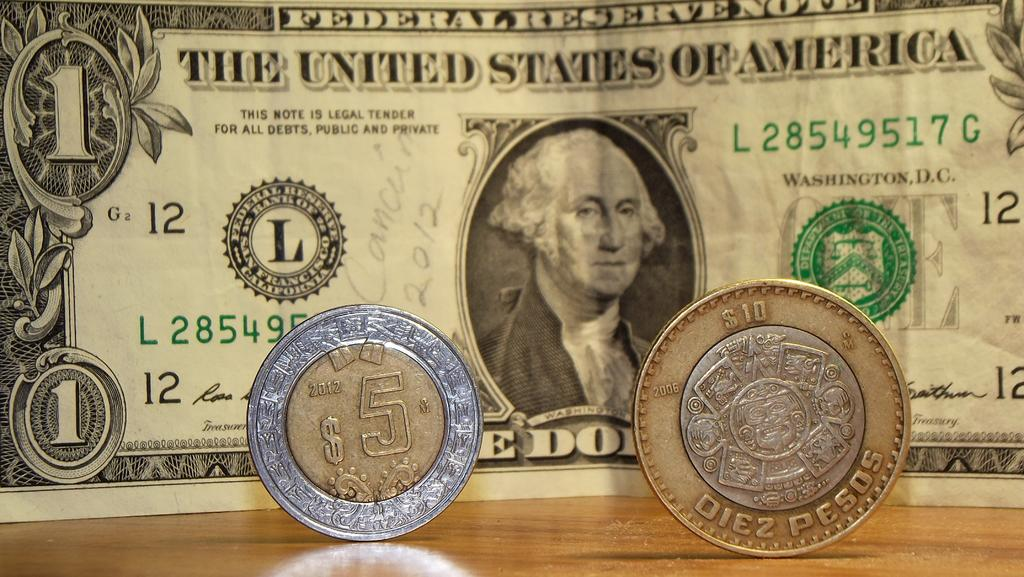<image>
Summarize the visual content of the image. A United States of America One Dollar bank note has FEDERAL RESERVE NOTE printed at the top. 